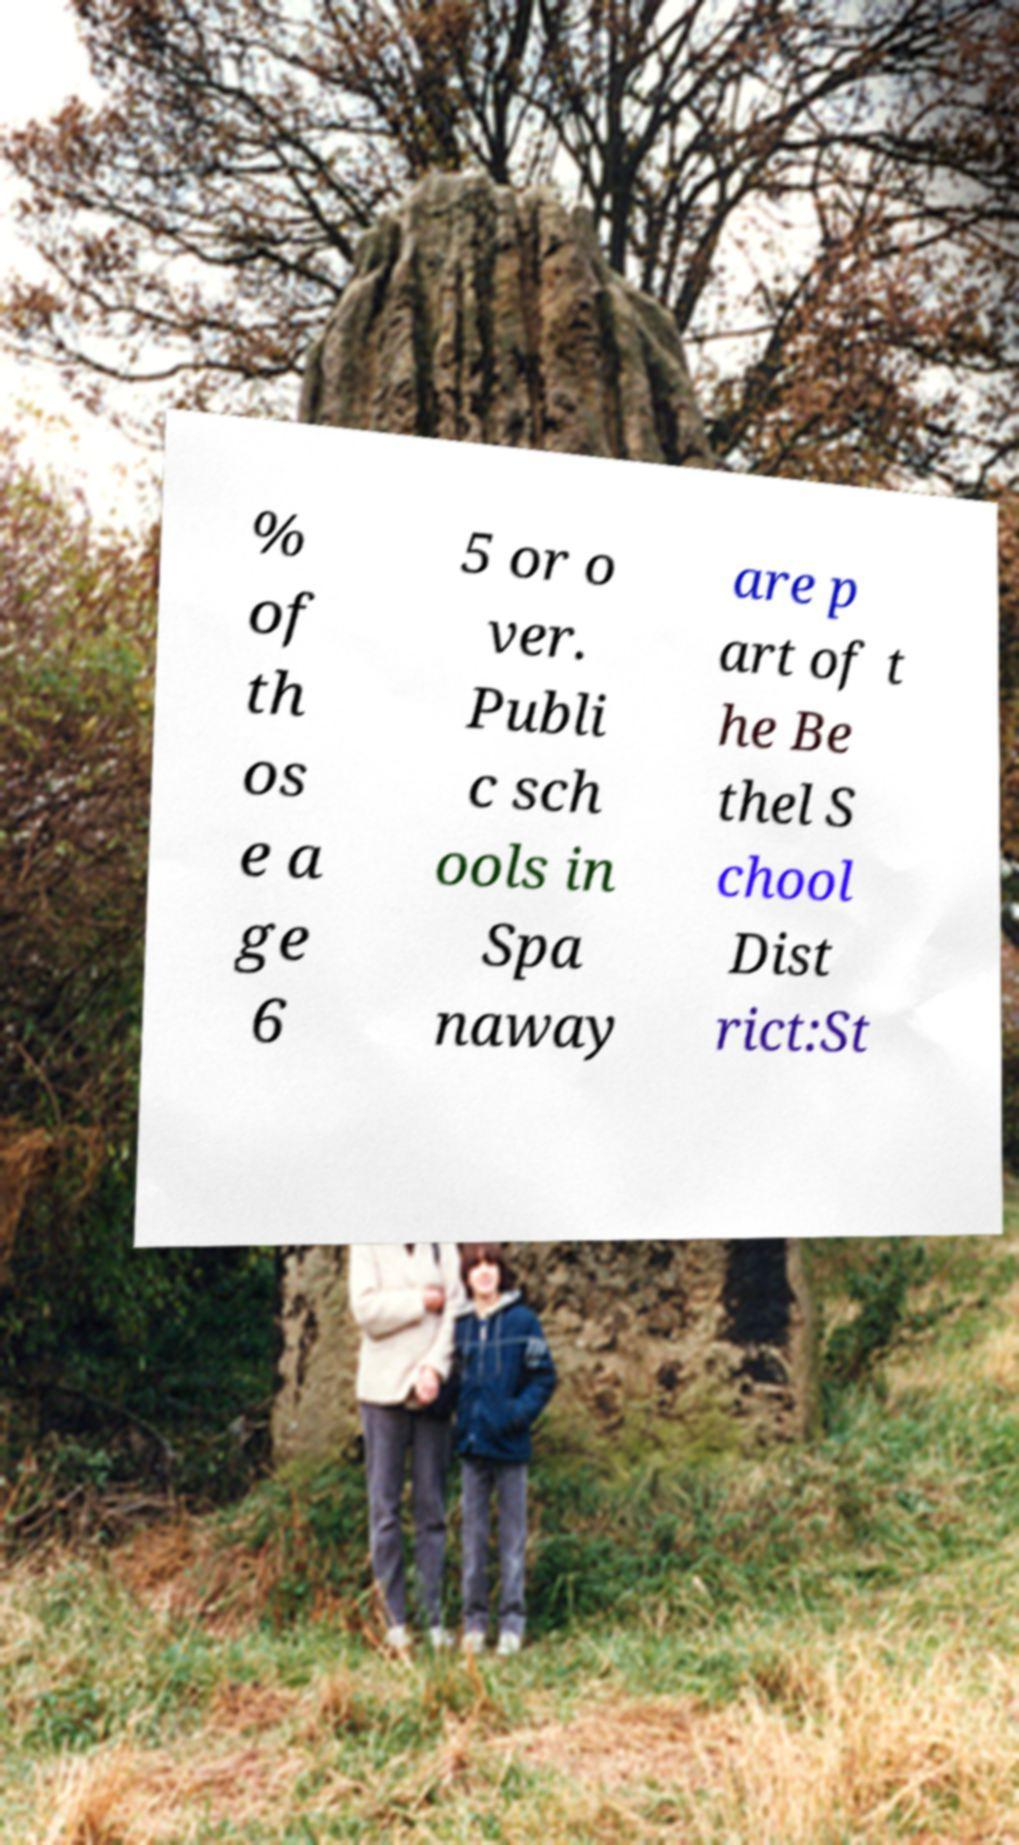Could you extract and type out the text from this image? % of th os e a ge 6 5 or o ver. Publi c sch ools in Spa naway are p art of t he Be thel S chool Dist rict:St 